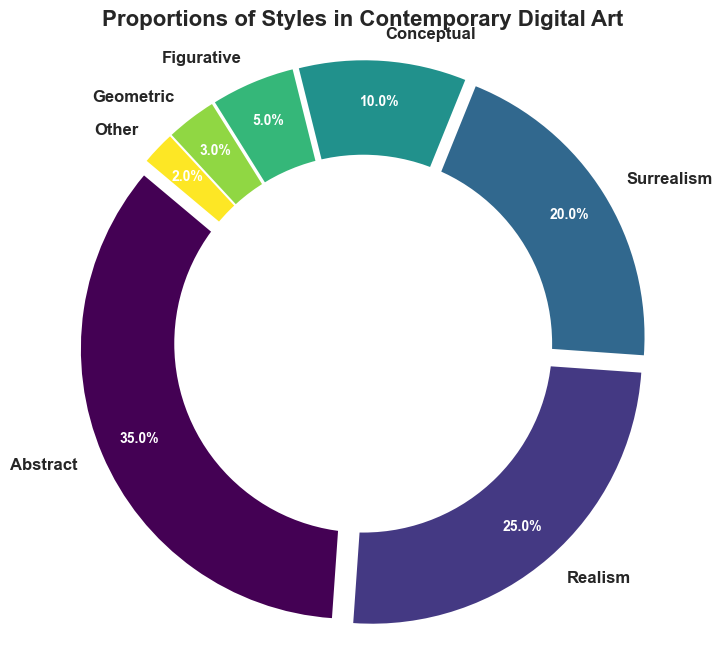What is the most prominent style in contemporary digital art according to the figure? The ring chart shows different proportions for each style. The style with the largest segment or highest percentage is the most prominent.
Answer: Abstract Which two styles combined make up more than half of the total proportion? By looking at the percentages for each style, adding the two largest proportions will determine if they make up over 50%. The two largest are Abstract (35%) and Realism (25%), which together sum up to 60%.
Answer: Abstract and Realism Is the proportion of Surrealism greater or smaller than the sum of Conceptual and Geometric? The figure shows Surrealism at 20%, Conceptual at 10%, and Geometric at 3%. Summing Conceptual and Geometric gives 13%, which is smaller than Surrealism's 20%.
Answer: Greater What is the combined proportion of the three least prominent styles in the figure? Identify the three smallest segments: Other (2%), Geometric (3%), and Figurative (5%). Add these proportions: 2% + 3% + 5% = 10%.
Answer: 10% How does the proportion of Figurative compare to Conceptual? The figure shows Figurative at 5% and Conceptual at 10%. Comparing the two, Conceptual has a larger proportion than Figurative.
Answer: Smaller What color is the segment representing Conceptual art? The figure uses a specific colormap, and the Conceptual segment will be visually identifiable by its color. Check the ring chart to see the color assigned to the Conceptual label.
Answer: The same color as the segment representing 10% By what percentage is Realism less than Abstract? Abstract is 35% and Realism is 25%. Subtract the Realism percentage from the Abstract percentage: 35% - 25% = 10%.
Answer: 10% Which style has the smallest proportion, and what is that proportion? The figure shows the smallest segment labeled with its percentage. The one labeled "Other" has the smallest value.
Answer: Other, 2% 